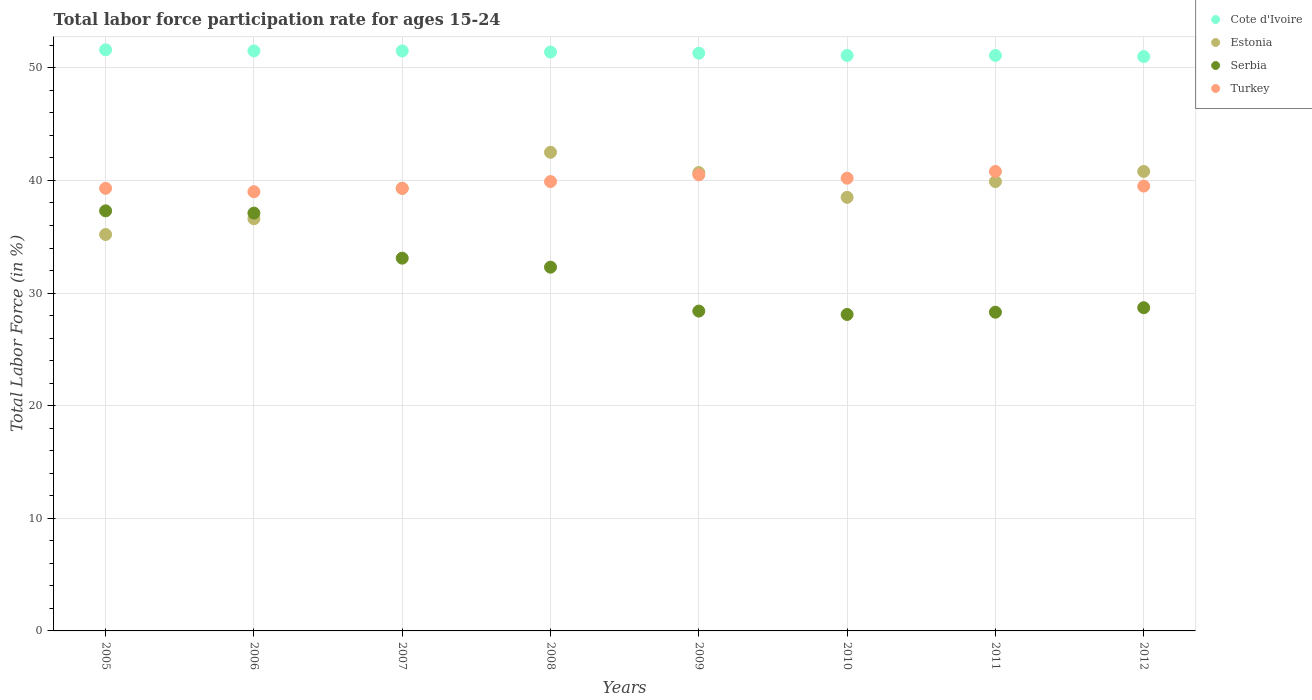What is the labor force participation rate in Turkey in 2009?
Your answer should be very brief. 40.5. Across all years, what is the maximum labor force participation rate in Estonia?
Offer a very short reply. 42.5. What is the total labor force participation rate in Serbia in the graph?
Offer a very short reply. 253.3. What is the average labor force participation rate in Serbia per year?
Ensure brevity in your answer.  31.66. In the year 2005, what is the difference between the labor force participation rate in Estonia and labor force participation rate in Turkey?
Give a very brief answer. -4.1. What is the ratio of the labor force participation rate in Estonia in 2006 to that in 2011?
Give a very brief answer. 0.92. Is the labor force participation rate in Estonia in 2007 less than that in 2012?
Give a very brief answer. Yes. What is the difference between the highest and the second highest labor force participation rate in Turkey?
Give a very brief answer. 0.3. What is the difference between the highest and the lowest labor force participation rate in Cote d'Ivoire?
Your answer should be very brief. 0.6. Is it the case that in every year, the sum of the labor force participation rate in Cote d'Ivoire and labor force participation rate in Serbia  is greater than the labor force participation rate in Turkey?
Your answer should be very brief. Yes. How many dotlines are there?
Keep it short and to the point. 4. What is the difference between two consecutive major ticks on the Y-axis?
Your answer should be very brief. 10. Are the values on the major ticks of Y-axis written in scientific E-notation?
Ensure brevity in your answer.  No. Does the graph contain any zero values?
Your answer should be compact. No. Does the graph contain grids?
Provide a succinct answer. Yes. How are the legend labels stacked?
Your answer should be compact. Vertical. What is the title of the graph?
Your response must be concise. Total labor force participation rate for ages 15-24. What is the Total Labor Force (in %) in Cote d'Ivoire in 2005?
Your answer should be very brief. 51.6. What is the Total Labor Force (in %) in Estonia in 2005?
Give a very brief answer. 35.2. What is the Total Labor Force (in %) of Serbia in 2005?
Offer a terse response. 37.3. What is the Total Labor Force (in %) in Turkey in 2005?
Provide a short and direct response. 39.3. What is the Total Labor Force (in %) in Cote d'Ivoire in 2006?
Provide a succinct answer. 51.5. What is the Total Labor Force (in %) of Estonia in 2006?
Offer a terse response. 36.6. What is the Total Labor Force (in %) in Serbia in 2006?
Keep it short and to the point. 37.1. What is the Total Labor Force (in %) in Turkey in 2006?
Give a very brief answer. 39. What is the Total Labor Force (in %) of Cote d'Ivoire in 2007?
Provide a succinct answer. 51.5. What is the Total Labor Force (in %) of Estonia in 2007?
Offer a terse response. 39.3. What is the Total Labor Force (in %) of Serbia in 2007?
Your answer should be compact. 33.1. What is the Total Labor Force (in %) in Turkey in 2007?
Provide a succinct answer. 39.3. What is the Total Labor Force (in %) in Cote d'Ivoire in 2008?
Ensure brevity in your answer.  51.4. What is the Total Labor Force (in %) in Estonia in 2008?
Your response must be concise. 42.5. What is the Total Labor Force (in %) in Serbia in 2008?
Make the answer very short. 32.3. What is the Total Labor Force (in %) of Turkey in 2008?
Your response must be concise. 39.9. What is the Total Labor Force (in %) in Cote d'Ivoire in 2009?
Provide a short and direct response. 51.3. What is the Total Labor Force (in %) in Estonia in 2009?
Your answer should be compact. 40.7. What is the Total Labor Force (in %) in Serbia in 2009?
Make the answer very short. 28.4. What is the Total Labor Force (in %) in Turkey in 2009?
Your answer should be very brief. 40.5. What is the Total Labor Force (in %) of Cote d'Ivoire in 2010?
Make the answer very short. 51.1. What is the Total Labor Force (in %) in Estonia in 2010?
Keep it short and to the point. 38.5. What is the Total Labor Force (in %) in Serbia in 2010?
Make the answer very short. 28.1. What is the Total Labor Force (in %) of Turkey in 2010?
Keep it short and to the point. 40.2. What is the Total Labor Force (in %) of Cote d'Ivoire in 2011?
Offer a very short reply. 51.1. What is the Total Labor Force (in %) in Estonia in 2011?
Offer a terse response. 39.9. What is the Total Labor Force (in %) in Serbia in 2011?
Provide a short and direct response. 28.3. What is the Total Labor Force (in %) of Turkey in 2011?
Your answer should be compact. 40.8. What is the Total Labor Force (in %) of Cote d'Ivoire in 2012?
Provide a succinct answer. 51. What is the Total Labor Force (in %) of Estonia in 2012?
Offer a terse response. 40.8. What is the Total Labor Force (in %) of Serbia in 2012?
Provide a succinct answer. 28.7. What is the Total Labor Force (in %) of Turkey in 2012?
Offer a very short reply. 39.5. Across all years, what is the maximum Total Labor Force (in %) of Cote d'Ivoire?
Provide a short and direct response. 51.6. Across all years, what is the maximum Total Labor Force (in %) of Estonia?
Give a very brief answer. 42.5. Across all years, what is the maximum Total Labor Force (in %) in Serbia?
Your answer should be very brief. 37.3. Across all years, what is the maximum Total Labor Force (in %) of Turkey?
Your answer should be compact. 40.8. Across all years, what is the minimum Total Labor Force (in %) in Cote d'Ivoire?
Your answer should be very brief. 51. Across all years, what is the minimum Total Labor Force (in %) in Estonia?
Provide a short and direct response. 35.2. Across all years, what is the minimum Total Labor Force (in %) in Serbia?
Provide a short and direct response. 28.1. What is the total Total Labor Force (in %) in Cote d'Ivoire in the graph?
Offer a very short reply. 410.5. What is the total Total Labor Force (in %) in Estonia in the graph?
Provide a succinct answer. 313.5. What is the total Total Labor Force (in %) of Serbia in the graph?
Your response must be concise. 253.3. What is the total Total Labor Force (in %) in Turkey in the graph?
Give a very brief answer. 318.5. What is the difference between the Total Labor Force (in %) of Estonia in 2005 and that in 2006?
Provide a succinct answer. -1.4. What is the difference between the Total Labor Force (in %) of Turkey in 2005 and that in 2006?
Offer a very short reply. 0.3. What is the difference between the Total Labor Force (in %) of Serbia in 2005 and that in 2007?
Your response must be concise. 4.2. What is the difference between the Total Labor Force (in %) in Turkey in 2005 and that in 2007?
Offer a very short reply. 0. What is the difference between the Total Labor Force (in %) of Cote d'Ivoire in 2005 and that in 2008?
Make the answer very short. 0.2. What is the difference between the Total Labor Force (in %) in Estonia in 2005 and that in 2008?
Offer a very short reply. -7.3. What is the difference between the Total Labor Force (in %) in Serbia in 2005 and that in 2009?
Your answer should be compact. 8.9. What is the difference between the Total Labor Force (in %) of Turkey in 2005 and that in 2009?
Offer a terse response. -1.2. What is the difference between the Total Labor Force (in %) of Cote d'Ivoire in 2005 and that in 2010?
Your answer should be compact. 0.5. What is the difference between the Total Labor Force (in %) of Estonia in 2005 and that in 2010?
Offer a very short reply. -3.3. What is the difference between the Total Labor Force (in %) of Serbia in 2005 and that in 2010?
Offer a very short reply. 9.2. What is the difference between the Total Labor Force (in %) of Cote d'Ivoire in 2005 and that in 2011?
Your response must be concise. 0.5. What is the difference between the Total Labor Force (in %) in Estonia in 2005 and that in 2011?
Your answer should be very brief. -4.7. What is the difference between the Total Labor Force (in %) of Cote d'Ivoire in 2005 and that in 2012?
Ensure brevity in your answer.  0.6. What is the difference between the Total Labor Force (in %) in Turkey in 2005 and that in 2012?
Offer a terse response. -0.2. What is the difference between the Total Labor Force (in %) of Cote d'Ivoire in 2006 and that in 2007?
Ensure brevity in your answer.  0. What is the difference between the Total Labor Force (in %) of Serbia in 2006 and that in 2007?
Provide a short and direct response. 4. What is the difference between the Total Labor Force (in %) of Turkey in 2006 and that in 2007?
Offer a terse response. -0.3. What is the difference between the Total Labor Force (in %) of Estonia in 2006 and that in 2008?
Your answer should be compact. -5.9. What is the difference between the Total Labor Force (in %) in Serbia in 2006 and that in 2008?
Provide a short and direct response. 4.8. What is the difference between the Total Labor Force (in %) of Turkey in 2006 and that in 2008?
Provide a short and direct response. -0.9. What is the difference between the Total Labor Force (in %) in Cote d'Ivoire in 2006 and that in 2009?
Keep it short and to the point. 0.2. What is the difference between the Total Labor Force (in %) in Serbia in 2006 and that in 2009?
Make the answer very short. 8.7. What is the difference between the Total Labor Force (in %) of Turkey in 2006 and that in 2009?
Make the answer very short. -1.5. What is the difference between the Total Labor Force (in %) in Estonia in 2006 and that in 2010?
Make the answer very short. -1.9. What is the difference between the Total Labor Force (in %) in Serbia in 2006 and that in 2010?
Your answer should be very brief. 9. What is the difference between the Total Labor Force (in %) of Cote d'Ivoire in 2006 and that in 2011?
Ensure brevity in your answer.  0.4. What is the difference between the Total Labor Force (in %) of Serbia in 2006 and that in 2011?
Offer a very short reply. 8.8. What is the difference between the Total Labor Force (in %) in Cote d'Ivoire in 2006 and that in 2012?
Offer a terse response. 0.5. What is the difference between the Total Labor Force (in %) in Estonia in 2006 and that in 2012?
Your answer should be compact. -4.2. What is the difference between the Total Labor Force (in %) in Serbia in 2006 and that in 2012?
Give a very brief answer. 8.4. What is the difference between the Total Labor Force (in %) in Turkey in 2006 and that in 2012?
Make the answer very short. -0.5. What is the difference between the Total Labor Force (in %) of Cote d'Ivoire in 2007 and that in 2008?
Make the answer very short. 0.1. What is the difference between the Total Labor Force (in %) of Estonia in 2007 and that in 2008?
Provide a succinct answer. -3.2. What is the difference between the Total Labor Force (in %) in Serbia in 2007 and that in 2008?
Your answer should be very brief. 0.8. What is the difference between the Total Labor Force (in %) of Turkey in 2007 and that in 2008?
Keep it short and to the point. -0.6. What is the difference between the Total Labor Force (in %) of Turkey in 2007 and that in 2009?
Make the answer very short. -1.2. What is the difference between the Total Labor Force (in %) in Cote d'Ivoire in 2007 and that in 2010?
Keep it short and to the point. 0.4. What is the difference between the Total Labor Force (in %) in Estonia in 2007 and that in 2011?
Provide a short and direct response. -0.6. What is the difference between the Total Labor Force (in %) of Turkey in 2007 and that in 2011?
Provide a succinct answer. -1.5. What is the difference between the Total Labor Force (in %) in Cote d'Ivoire in 2007 and that in 2012?
Offer a terse response. 0.5. What is the difference between the Total Labor Force (in %) in Estonia in 2007 and that in 2012?
Ensure brevity in your answer.  -1.5. What is the difference between the Total Labor Force (in %) of Serbia in 2007 and that in 2012?
Ensure brevity in your answer.  4.4. What is the difference between the Total Labor Force (in %) of Turkey in 2007 and that in 2012?
Your answer should be very brief. -0.2. What is the difference between the Total Labor Force (in %) in Cote d'Ivoire in 2008 and that in 2009?
Provide a succinct answer. 0.1. What is the difference between the Total Labor Force (in %) of Turkey in 2008 and that in 2009?
Provide a succinct answer. -0.6. What is the difference between the Total Labor Force (in %) of Cote d'Ivoire in 2008 and that in 2011?
Your answer should be very brief. 0.3. What is the difference between the Total Labor Force (in %) of Estonia in 2008 and that in 2011?
Your answer should be very brief. 2.6. What is the difference between the Total Labor Force (in %) of Serbia in 2008 and that in 2011?
Provide a succinct answer. 4. What is the difference between the Total Labor Force (in %) in Turkey in 2008 and that in 2011?
Your response must be concise. -0.9. What is the difference between the Total Labor Force (in %) in Cote d'Ivoire in 2008 and that in 2012?
Provide a succinct answer. 0.4. What is the difference between the Total Labor Force (in %) in Serbia in 2008 and that in 2012?
Provide a succinct answer. 3.6. What is the difference between the Total Labor Force (in %) in Estonia in 2009 and that in 2010?
Offer a terse response. 2.2. What is the difference between the Total Labor Force (in %) in Serbia in 2009 and that in 2010?
Keep it short and to the point. 0.3. What is the difference between the Total Labor Force (in %) of Turkey in 2009 and that in 2010?
Give a very brief answer. 0.3. What is the difference between the Total Labor Force (in %) in Estonia in 2009 and that in 2011?
Make the answer very short. 0.8. What is the difference between the Total Labor Force (in %) in Turkey in 2009 and that in 2011?
Offer a very short reply. -0.3. What is the difference between the Total Labor Force (in %) of Turkey in 2009 and that in 2012?
Ensure brevity in your answer.  1. What is the difference between the Total Labor Force (in %) of Cote d'Ivoire in 2010 and that in 2011?
Your response must be concise. 0. What is the difference between the Total Labor Force (in %) of Estonia in 2010 and that in 2011?
Offer a very short reply. -1.4. What is the difference between the Total Labor Force (in %) of Serbia in 2010 and that in 2011?
Provide a short and direct response. -0.2. What is the difference between the Total Labor Force (in %) in Turkey in 2010 and that in 2011?
Your answer should be compact. -0.6. What is the difference between the Total Labor Force (in %) of Cote d'Ivoire in 2010 and that in 2012?
Your response must be concise. 0.1. What is the difference between the Total Labor Force (in %) in Estonia in 2010 and that in 2012?
Offer a very short reply. -2.3. What is the difference between the Total Labor Force (in %) of Serbia in 2010 and that in 2012?
Keep it short and to the point. -0.6. What is the difference between the Total Labor Force (in %) in Turkey in 2010 and that in 2012?
Give a very brief answer. 0.7. What is the difference between the Total Labor Force (in %) in Cote d'Ivoire in 2011 and that in 2012?
Offer a very short reply. 0.1. What is the difference between the Total Labor Force (in %) in Estonia in 2011 and that in 2012?
Provide a short and direct response. -0.9. What is the difference between the Total Labor Force (in %) of Serbia in 2011 and that in 2012?
Your answer should be compact. -0.4. What is the difference between the Total Labor Force (in %) of Turkey in 2011 and that in 2012?
Offer a very short reply. 1.3. What is the difference between the Total Labor Force (in %) in Cote d'Ivoire in 2005 and the Total Labor Force (in %) in Turkey in 2006?
Your answer should be very brief. 12.6. What is the difference between the Total Labor Force (in %) in Estonia in 2005 and the Total Labor Force (in %) in Turkey in 2006?
Offer a terse response. -3.8. What is the difference between the Total Labor Force (in %) in Cote d'Ivoire in 2005 and the Total Labor Force (in %) in Estonia in 2007?
Your response must be concise. 12.3. What is the difference between the Total Labor Force (in %) of Cote d'Ivoire in 2005 and the Total Labor Force (in %) of Turkey in 2007?
Give a very brief answer. 12.3. What is the difference between the Total Labor Force (in %) of Estonia in 2005 and the Total Labor Force (in %) of Serbia in 2007?
Ensure brevity in your answer.  2.1. What is the difference between the Total Labor Force (in %) in Estonia in 2005 and the Total Labor Force (in %) in Turkey in 2007?
Offer a terse response. -4.1. What is the difference between the Total Labor Force (in %) of Cote d'Ivoire in 2005 and the Total Labor Force (in %) of Estonia in 2008?
Provide a short and direct response. 9.1. What is the difference between the Total Labor Force (in %) of Cote d'Ivoire in 2005 and the Total Labor Force (in %) of Serbia in 2008?
Provide a succinct answer. 19.3. What is the difference between the Total Labor Force (in %) in Cote d'Ivoire in 2005 and the Total Labor Force (in %) in Turkey in 2008?
Give a very brief answer. 11.7. What is the difference between the Total Labor Force (in %) in Serbia in 2005 and the Total Labor Force (in %) in Turkey in 2008?
Offer a very short reply. -2.6. What is the difference between the Total Labor Force (in %) of Cote d'Ivoire in 2005 and the Total Labor Force (in %) of Serbia in 2009?
Your response must be concise. 23.2. What is the difference between the Total Labor Force (in %) in Cote d'Ivoire in 2005 and the Total Labor Force (in %) in Turkey in 2009?
Provide a succinct answer. 11.1. What is the difference between the Total Labor Force (in %) in Serbia in 2005 and the Total Labor Force (in %) in Turkey in 2009?
Your response must be concise. -3.2. What is the difference between the Total Labor Force (in %) in Cote d'Ivoire in 2005 and the Total Labor Force (in %) in Serbia in 2010?
Ensure brevity in your answer.  23.5. What is the difference between the Total Labor Force (in %) of Estonia in 2005 and the Total Labor Force (in %) of Serbia in 2010?
Your response must be concise. 7.1. What is the difference between the Total Labor Force (in %) of Estonia in 2005 and the Total Labor Force (in %) of Turkey in 2010?
Give a very brief answer. -5. What is the difference between the Total Labor Force (in %) of Serbia in 2005 and the Total Labor Force (in %) of Turkey in 2010?
Your response must be concise. -2.9. What is the difference between the Total Labor Force (in %) of Cote d'Ivoire in 2005 and the Total Labor Force (in %) of Serbia in 2011?
Give a very brief answer. 23.3. What is the difference between the Total Labor Force (in %) in Serbia in 2005 and the Total Labor Force (in %) in Turkey in 2011?
Provide a short and direct response. -3.5. What is the difference between the Total Labor Force (in %) in Cote d'Ivoire in 2005 and the Total Labor Force (in %) in Estonia in 2012?
Ensure brevity in your answer.  10.8. What is the difference between the Total Labor Force (in %) of Cote d'Ivoire in 2005 and the Total Labor Force (in %) of Serbia in 2012?
Keep it short and to the point. 22.9. What is the difference between the Total Labor Force (in %) in Cote d'Ivoire in 2005 and the Total Labor Force (in %) in Turkey in 2012?
Ensure brevity in your answer.  12.1. What is the difference between the Total Labor Force (in %) in Estonia in 2005 and the Total Labor Force (in %) in Serbia in 2012?
Keep it short and to the point. 6.5. What is the difference between the Total Labor Force (in %) in Estonia in 2005 and the Total Labor Force (in %) in Turkey in 2012?
Make the answer very short. -4.3. What is the difference between the Total Labor Force (in %) in Estonia in 2006 and the Total Labor Force (in %) in Serbia in 2007?
Provide a short and direct response. 3.5. What is the difference between the Total Labor Force (in %) in Estonia in 2006 and the Total Labor Force (in %) in Turkey in 2007?
Make the answer very short. -2.7. What is the difference between the Total Labor Force (in %) in Cote d'Ivoire in 2006 and the Total Labor Force (in %) in Turkey in 2008?
Give a very brief answer. 11.6. What is the difference between the Total Labor Force (in %) of Serbia in 2006 and the Total Labor Force (in %) of Turkey in 2008?
Ensure brevity in your answer.  -2.8. What is the difference between the Total Labor Force (in %) of Cote d'Ivoire in 2006 and the Total Labor Force (in %) of Serbia in 2009?
Make the answer very short. 23.1. What is the difference between the Total Labor Force (in %) of Serbia in 2006 and the Total Labor Force (in %) of Turkey in 2009?
Provide a short and direct response. -3.4. What is the difference between the Total Labor Force (in %) in Cote d'Ivoire in 2006 and the Total Labor Force (in %) in Estonia in 2010?
Ensure brevity in your answer.  13. What is the difference between the Total Labor Force (in %) in Cote d'Ivoire in 2006 and the Total Labor Force (in %) in Serbia in 2010?
Your answer should be very brief. 23.4. What is the difference between the Total Labor Force (in %) of Estonia in 2006 and the Total Labor Force (in %) of Serbia in 2010?
Give a very brief answer. 8.5. What is the difference between the Total Labor Force (in %) in Serbia in 2006 and the Total Labor Force (in %) in Turkey in 2010?
Your answer should be very brief. -3.1. What is the difference between the Total Labor Force (in %) in Cote d'Ivoire in 2006 and the Total Labor Force (in %) in Estonia in 2011?
Your response must be concise. 11.6. What is the difference between the Total Labor Force (in %) of Cote d'Ivoire in 2006 and the Total Labor Force (in %) of Serbia in 2011?
Make the answer very short. 23.2. What is the difference between the Total Labor Force (in %) in Cote d'Ivoire in 2006 and the Total Labor Force (in %) in Turkey in 2011?
Offer a terse response. 10.7. What is the difference between the Total Labor Force (in %) in Estonia in 2006 and the Total Labor Force (in %) in Serbia in 2011?
Your response must be concise. 8.3. What is the difference between the Total Labor Force (in %) in Estonia in 2006 and the Total Labor Force (in %) in Turkey in 2011?
Ensure brevity in your answer.  -4.2. What is the difference between the Total Labor Force (in %) of Serbia in 2006 and the Total Labor Force (in %) of Turkey in 2011?
Keep it short and to the point. -3.7. What is the difference between the Total Labor Force (in %) in Cote d'Ivoire in 2006 and the Total Labor Force (in %) in Serbia in 2012?
Provide a succinct answer. 22.8. What is the difference between the Total Labor Force (in %) of Cote d'Ivoire in 2006 and the Total Labor Force (in %) of Turkey in 2012?
Your answer should be very brief. 12. What is the difference between the Total Labor Force (in %) in Estonia in 2006 and the Total Labor Force (in %) in Turkey in 2012?
Ensure brevity in your answer.  -2.9. What is the difference between the Total Labor Force (in %) in Cote d'Ivoire in 2007 and the Total Labor Force (in %) in Estonia in 2008?
Offer a very short reply. 9. What is the difference between the Total Labor Force (in %) of Cote d'Ivoire in 2007 and the Total Labor Force (in %) of Turkey in 2008?
Provide a short and direct response. 11.6. What is the difference between the Total Labor Force (in %) in Cote d'Ivoire in 2007 and the Total Labor Force (in %) in Estonia in 2009?
Your answer should be very brief. 10.8. What is the difference between the Total Labor Force (in %) in Cote d'Ivoire in 2007 and the Total Labor Force (in %) in Serbia in 2009?
Make the answer very short. 23.1. What is the difference between the Total Labor Force (in %) in Cote d'Ivoire in 2007 and the Total Labor Force (in %) in Turkey in 2009?
Give a very brief answer. 11. What is the difference between the Total Labor Force (in %) of Estonia in 2007 and the Total Labor Force (in %) of Serbia in 2009?
Give a very brief answer. 10.9. What is the difference between the Total Labor Force (in %) of Serbia in 2007 and the Total Labor Force (in %) of Turkey in 2009?
Give a very brief answer. -7.4. What is the difference between the Total Labor Force (in %) in Cote d'Ivoire in 2007 and the Total Labor Force (in %) in Estonia in 2010?
Your answer should be very brief. 13. What is the difference between the Total Labor Force (in %) in Cote d'Ivoire in 2007 and the Total Labor Force (in %) in Serbia in 2010?
Your answer should be very brief. 23.4. What is the difference between the Total Labor Force (in %) in Cote d'Ivoire in 2007 and the Total Labor Force (in %) in Turkey in 2010?
Provide a succinct answer. 11.3. What is the difference between the Total Labor Force (in %) in Estonia in 2007 and the Total Labor Force (in %) in Serbia in 2010?
Keep it short and to the point. 11.2. What is the difference between the Total Labor Force (in %) of Estonia in 2007 and the Total Labor Force (in %) of Turkey in 2010?
Your answer should be compact. -0.9. What is the difference between the Total Labor Force (in %) of Cote d'Ivoire in 2007 and the Total Labor Force (in %) of Serbia in 2011?
Keep it short and to the point. 23.2. What is the difference between the Total Labor Force (in %) in Cote d'Ivoire in 2007 and the Total Labor Force (in %) in Turkey in 2011?
Your response must be concise. 10.7. What is the difference between the Total Labor Force (in %) of Estonia in 2007 and the Total Labor Force (in %) of Turkey in 2011?
Keep it short and to the point. -1.5. What is the difference between the Total Labor Force (in %) of Cote d'Ivoire in 2007 and the Total Labor Force (in %) of Serbia in 2012?
Your response must be concise. 22.8. What is the difference between the Total Labor Force (in %) of Cote d'Ivoire in 2007 and the Total Labor Force (in %) of Turkey in 2012?
Your response must be concise. 12. What is the difference between the Total Labor Force (in %) of Estonia in 2007 and the Total Labor Force (in %) of Turkey in 2012?
Your answer should be very brief. -0.2. What is the difference between the Total Labor Force (in %) of Serbia in 2007 and the Total Labor Force (in %) of Turkey in 2012?
Your response must be concise. -6.4. What is the difference between the Total Labor Force (in %) of Cote d'Ivoire in 2008 and the Total Labor Force (in %) of Serbia in 2010?
Your answer should be compact. 23.3. What is the difference between the Total Labor Force (in %) of Cote d'Ivoire in 2008 and the Total Labor Force (in %) of Turkey in 2010?
Provide a short and direct response. 11.2. What is the difference between the Total Labor Force (in %) in Estonia in 2008 and the Total Labor Force (in %) in Serbia in 2010?
Offer a very short reply. 14.4. What is the difference between the Total Labor Force (in %) of Estonia in 2008 and the Total Labor Force (in %) of Turkey in 2010?
Your response must be concise. 2.3. What is the difference between the Total Labor Force (in %) of Serbia in 2008 and the Total Labor Force (in %) of Turkey in 2010?
Your answer should be compact. -7.9. What is the difference between the Total Labor Force (in %) in Cote d'Ivoire in 2008 and the Total Labor Force (in %) in Estonia in 2011?
Offer a terse response. 11.5. What is the difference between the Total Labor Force (in %) of Cote d'Ivoire in 2008 and the Total Labor Force (in %) of Serbia in 2011?
Your answer should be very brief. 23.1. What is the difference between the Total Labor Force (in %) of Cote d'Ivoire in 2008 and the Total Labor Force (in %) of Turkey in 2011?
Make the answer very short. 10.6. What is the difference between the Total Labor Force (in %) in Cote d'Ivoire in 2008 and the Total Labor Force (in %) in Estonia in 2012?
Your answer should be compact. 10.6. What is the difference between the Total Labor Force (in %) in Cote d'Ivoire in 2008 and the Total Labor Force (in %) in Serbia in 2012?
Offer a very short reply. 22.7. What is the difference between the Total Labor Force (in %) in Cote d'Ivoire in 2008 and the Total Labor Force (in %) in Turkey in 2012?
Ensure brevity in your answer.  11.9. What is the difference between the Total Labor Force (in %) of Estonia in 2008 and the Total Labor Force (in %) of Serbia in 2012?
Give a very brief answer. 13.8. What is the difference between the Total Labor Force (in %) of Cote d'Ivoire in 2009 and the Total Labor Force (in %) of Estonia in 2010?
Keep it short and to the point. 12.8. What is the difference between the Total Labor Force (in %) of Cote d'Ivoire in 2009 and the Total Labor Force (in %) of Serbia in 2010?
Provide a succinct answer. 23.2. What is the difference between the Total Labor Force (in %) in Cote d'Ivoire in 2009 and the Total Labor Force (in %) in Turkey in 2010?
Your response must be concise. 11.1. What is the difference between the Total Labor Force (in %) in Serbia in 2009 and the Total Labor Force (in %) in Turkey in 2010?
Keep it short and to the point. -11.8. What is the difference between the Total Labor Force (in %) of Cote d'Ivoire in 2009 and the Total Labor Force (in %) of Turkey in 2011?
Keep it short and to the point. 10.5. What is the difference between the Total Labor Force (in %) of Estonia in 2009 and the Total Labor Force (in %) of Serbia in 2011?
Provide a short and direct response. 12.4. What is the difference between the Total Labor Force (in %) in Estonia in 2009 and the Total Labor Force (in %) in Turkey in 2011?
Provide a short and direct response. -0.1. What is the difference between the Total Labor Force (in %) in Serbia in 2009 and the Total Labor Force (in %) in Turkey in 2011?
Your answer should be compact. -12.4. What is the difference between the Total Labor Force (in %) of Cote d'Ivoire in 2009 and the Total Labor Force (in %) of Estonia in 2012?
Give a very brief answer. 10.5. What is the difference between the Total Labor Force (in %) of Cote d'Ivoire in 2009 and the Total Labor Force (in %) of Serbia in 2012?
Provide a succinct answer. 22.6. What is the difference between the Total Labor Force (in %) of Cote d'Ivoire in 2009 and the Total Labor Force (in %) of Turkey in 2012?
Offer a very short reply. 11.8. What is the difference between the Total Labor Force (in %) of Estonia in 2009 and the Total Labor Force (in %) of Turkey in 2012?
Provide a short and direct response. 1.2. What is the difference between the Total Labor Force (in %) in Cote d'Ivoire in 2010 and the Total Labor Force (in %) in Estonia in 2011?
Make the answer very short. 11.2. What is the difference between the Total Labor Force (in %) of Cote d'Ivoire in 2010 and the Total Labor Force (in %) of Serbia in 2011?
Provide a short and direct response. 22.8. What is the difference between the Total Labor Force (in %) in Cote d'Ivoire in 2010 and the Total Labor Force (in %) in Turkey in 2011?
Your answer should be compact. 10.3. What is the difference between the Total Labor Force (in %) of Estonia in 2010 and the Total Labor Force (in %) of Serbia in 2011?
Provide a succinct answer. 10.2. What is the difference between the Total Labor Force (in %) in Serbia in 2010 and the Total Labor Force (in %) in Turkey in 2011?
Provide a short and direct response. -12.7. What is the difference between the Total Labor Force (in %) in Cote d'Ivoire in 2010 and the Total Labor Force (in %) in Estonia in 2012?
Offer a terse response. 10.3. What is the difference between the Total Labor Force (in %) in Cote d'Ivoire in 2010 and the Total Labor Force (in %) in Serbia in 2012?
Your answer should be very brief. 22.4. What is the difference between the Total Labor Force (in %) of Cote d'Ivoire in 2010 and the Total Labor Force (in %) of Turkey in 2012?
Offer a very short reply. 11.6. What is the difference between the Total Labor Force (in %) of Cote d'Ivoire in 2011 and the Total Labor Force (in %) of Serbia in 2012?
Keep it short and to the point. 22.4. What is the difference between the Total Labor Force (in %) of Estonia in 2011 and the Total Labor Force (in %) of Turkey in 2012?
Make the answer very short. 0.4. What is the difference between the Total Labor Force (in %) of Serbia in 2011 and the Total Labor Force (in %) of Turkey in 2012?
Provide a succinct answer. -11.2. What is the average Total Labor Force (in %) of Cote d'Ivoire per year?
Provide a succinct answer. 51.31. What is the average Total Labor Force (in %) of Estonia per year?
Your answer should be very brief. 39.19. What is the average Total Labor Force (in %) of Serbia per year?
Ensure brevity in your answer.  31.66. What is the average Total Labor Force (in %) in Turkey per year?
Offer a very short reply. 39.81. In the year 2005, what is the difference between the Total Labor Force (in %) of Cote d'Ivoire and Total Labor Force (in %) of Serbia?
Offer a very short reply. 14.3. In the year 2005, what is the difference between the Total Labor Force (in %) in Cote d'Ivoire and Total Labor Force (in %) in Turkey?
Offer a terse response. 12.3. In the year 2005, what is the difference between the Total Labor Force (in %) of Estonia and Total Labor Force (in %) of Serbia?
Offer a terse response. -2.1. In the year 2005, what is the difference between the Total Labor Force (in %) in Estonia and Total Labor Force (in %) in Turkey?
Make the answer very short. -4.1. In the year 2005, what is the difference between the Total Labor Force (in %) of Serbia and Total Labor Force (in %) of Turkey?
Your answer should be very brief. -2. In the year 2006, what is the difference between the Total Labor Force (in %) of Cote d'Ivoire and Total Labor Force (in %) of Estonia?
Your answer should be very brief. 14.9. In the year 2006, what is the difference between the Total Labor Force (in %) in Cote d'Ivoire and Total Labor Force (in %) in Serbia?
Offer a very short reply. 14.4. In the year 2006, what is the difference between the Total Labor Force (in %) in Estonia and Total Labor Force (in %) in Serbia?
Give a very brief answer. -0.5. In the year 2006, what is the difference between the Total Labor Force (in %) of Estonia and Total Labor Force (in %) of Turkey?
Provide a short and direct response. -2.4. In the year 2007, what is the difference between the Total Labor Force (in %) of Cote d'Ivoire and Total Labor Force (in %) of Turkey?
Give a very brief answer. 12.2. In the year 2007, what is the difference between the Total Labor Force (in %) in Estonia and Total Labor Force (in %) in Serbia?
Provide a succinct answer. 6.2. In the year 2007, what is the difference between the Total Labor Force (in %) in Estonia and Total Labor Force (in %) in Turkey?
Offer a terse response. 0. In the year 2007, what is the difference between the Total Labor Force (in %) of Serbia and Total Labor Force (in %) of Turkey?
Your answer should be very brief. -6.2. In the year 2008, what is the difference between the Total Labor Force (in %) in Cote d'Ivoire and Total Labor Force (in %) in Serbia?
Give a very brief answer. 19.1. In the year 2008, what is the difference between the Total Labor Force (in %) of Estonia and Total Labor Force (in %) of Turkey?
Make the answer very short. 2.6. In the year 2009, what is the difference between the Total Labor Force (in %) in Cote d'Ivoire and Total Labor Force (in %) in Estonia?
Offer a terse response. 10.6. In the year 2009, what is the difference between the Total Labor Force (in %) of Cote d'Ivoire and Total Labor Force (in %) of Serbia?
Provide a short and direct response. 22.9. In the year 2009, what is the difference between the Total Labor Force (in %) in Cote d'Ivoire and Total Labor Force (in %) in Turkey?
Your response must be concise. 10.8. In the year 2009, what is the difference between the Total Labor Force (in %) in Serbia and Total Labor Force (in %) in Turkey?
Provide a succinct answer. -12.1. In the year 2010, what is the difference between the Total Labor Force (in %) in Cote d'Ivoire and Total Labor Force (in %) in Estonia?
Provide a short and direct response. 12.6. In the year 2010, what is the difference between the Total Labor Force (in %) of Cote d'Ivoire and Total Labor Force (in %) of Turkey?
Ensure brevity in your answer.  10.9. In the year 2010, what is the difference between the Total Labor Force (in %) of Estonia and Total Labor Force (in %) of Serbia?
Keep it short and to the point. 10.4. In the year 2010, what is the difference between the Total Labor Force (in %) in Serbia and Total Labor Force (in %) in Turkey?
Make the answer very short. -12.1. In the year 2011, what is the difference between the Total Labor Force (in %) in Cote d'Ivoire and Total Labor Force (in %) in Estonia?
Offer a terse response. 11.2. In the year 2011, what is the difference between the Total Labor Force (in %) in Cote d'Ivoire and Total Labor Force (in %) in Serbia?
Your answer should be very brief. 22.8. In the year 2011, what is the difference between the Total Labor Force (in %) in Serbia and Total Labor Force (in %) in Turkey?
Keep it short and to the point. -12.5. In the year 2012, what is the difference between the Total Labor Force (in %) in Cote d'Ivoire and Total Labor Force (in %) in Serbia?
Offer a very short reply. 22.3. In the year 2012, what is the difference between the Total Labor Force (in %) in Cote d'Ivoire and Total Labor Force (in %) in Turkey?
Your answer should be compact. 11.5. In the year 2012, what is the difference between the Total Labor Force (in %) of Estonia and Total Labor Force (in %) of Serbia?
Your answer should be very brief. 12.1. In the year 2012, what is the difference between the Total Labor Force (in %) of Serbia and Total Labor Force (in %) of Turkey?
Give a very brief answer. -10.8. What is the ratio of the Total Labor Force (in %) in Cote d'Ivoire in 2005 to that in 2006?
Your response must be concise. 1. What is the ratio of the Total Labor Force (in %) in Estonia in 2005 to that in 2006?
Offer a terse response. 0.96. What is the ratio of the Total Labor Force (in %) of Serbia in 2005 to that in 2006?
Make the answer very short. 1.01. What is the ratio of the Total Labor Force (in %) in Turkey in 2005 to that in 2006?
Ensure brevity in your answer.  1.01. What is the ratio of the Total Labor Force (in %) in Cote d'Ivoire in 2005 to that in 2007?
Offer a very short reply. 1. What is the ratio of the Total Labor Force (in %) of Estonia in 2005 to that in 2007?
Your response must be concise. 0.9. What is the ratio of the Total Labor Force (in %) in Serbia in 2005 to that in 2007?
Ensure brevity in your answer.  1.13. What is the ratio of the Total Labor Force (in %) in Cote d'Ivoire in 2005 to that in 2008?
Provide a short and direct response. 1. What is the ratio of the Total Labor Force (in %) in Estonia in 2005 to that in 2008?
Your answer should be very brief. 0.83. What is the ratio of the Total Labor Force (in %) in Serbia in 2005 to that in 2008?
Your answer should be compact. 1.15. What is the ratio of the Total Labor Force (in %) in Turkey in 2005 to that in 2008?
Give a very brief answer. 0.98. What is the ratio of the Total Labor Force (in %) of Cote d'Ivoire in 2005 to that in 2009?
Ensure brevity in your answer.  1.01. What is the ratio of the Total Labor Force (in %) in Estonia in 2005 to that in 2009?
Provide a succinct answer. 0.86. What is the ratio of the Total Labor Force (in %) of Serbia in 2005 to that in 2009?
Provide a succinct answer. 1.31. What is the ratio of the Total Labor Force (in %) in Turkey in 2005 to that in 2009?
Offer a very short reply. 0.97. What is the ratio of the Total Labor Force (in %) of Cote d'Ivoire in 2005 to that in 2010?
Make the answer very short. 1.01. What is the ratio of the Total Labor Force (in %) of Estonia in 2005 to that in 2010?
Keep it short and to the point. 0.91. What is the ratio of the Total Labor Force (in %) of Serbia in 2005 to that in 2010?
Provide a short and direct response. 1.33. What is the ratio of the Total Labor Force (in %) in Turkey in 2005 to that in 2010?
Your response must be concise. 0.98. What is the ratio of the Total Labor Force (in %) in Cote d'Ivoire in 2005 to that in 2011?
Make the answer very short. 1.01. What is the ratio of the Total Labor Force (in %) in Estonia in 2005 to that in 2011?
Provide a succinct answer. 0.88. What is the ratio of the Total Labor Force (in %) of Serbia in 2005 to that in 2011?
Provide a short and direct response. 1.32. What is the ratio of the Total Labor Force (in %) of Turkey in 2005 to that in 2011?
Your answer should be very brief. 0.96. What is the ratio of the Total Labor Force (in %) in Cote d'Ivoire in 2005 to that in 2012?
Your response must be concise. 1.01. What is the ratio of the Total Labor Force (in %) of Estonia in 2005 to that in 2012?
Provide a short and direct response. 0.86. What is the ratio of the Total Labor Force (in %) in Serbia in 2005 to that in 2012?
Provide a short and direct response. 1.3. What is the ratio of the Total Labor Force (in %) in Cote d'Ivoire in 2006 to that in 2007?
Offer a very short reply. 1. What is the ratio of the Total Labor Force (in %) in Estonia in 2006 to that in 2007?
Keep it short and to the point. 0.93. What is the ratio of the Total Labor Force (in %) of Serbia in 2006 to that in 2007?
Provide a succinct answer. 1.12. What is the ratio of the Total Labor Force (in %) in Cote d'Ivoire in 2006 to that in 2008?
Give a very brief answer. 1. What is the ratio of the Total Labor Force (in %) in Estonia in 2006 to that in 2008?
Ensure brevity in your answer.  0.86. What is the ratio of the Total Labor Force (in %) of Serbia in 2006 to that in 2008?
Offer a very short reply. 1.15. What is the ratio of the Total Labor Force (in %) of Turkey in 2006 to that in 2008?
Your response must be concise. 0.98. What is the ratio of the Total Labor Force (in %) in Cote d'Ivoire in 2006 to that in 2009?
Provide a short and direct response. 1. What is the ratio of the Total Labor Force (in %) of Estonia in 2006 to that in 2009?
Make the answer very short. 0.9. What is the ratio of the Total Labor Force (in %) of Serbia in 2006 to that in 2009?
Make the answer very short. 1.31. What is the ratio of the Total Labor Force (in %) in Estonia in 2006 to that in 2010?
Offer a very short reply. 0.95. What is the ratio of the Total Labor Force (in %) in Serbia in 2006 to that in 2010?
Offer a terse response. 1.32. What is the ratio of the Total Labor Force (in %) in Turkey in 2006 to that in 2010?
Provide a short and direct response. 0.97. What is the ratio of the Total Labor Force (in %) in Cote d'Ivoire in 2006 to that in 2011?
Your answer should be compact. 1.01. What is the ratio of the Total Labor Force (in %) of Estonia in 2006 to that in 2011?
Your answer should be compact. 0.92. What is the ratio of the Total Labor Force (in %) in Serbia in 2006 to that in 2011?
Offer a very short reply. 1.31. What is the ratio of the Total Labor Force (in %) of Turkey in 2006 to that in 2011?
Provide a succinct answer. 0.96. What is the ratio of the Total Labor Force (in %) of Cote d'Ivoire in 2006 to that in 2012?
Offer a terse response. 1.01. What is the ratio of the Total Labor Force (in %) in Estonia in 2006 to that in 2012?
Give a very brief answer. 0.9. What is the ratio of the Total Labor Force (in %) in Serbia in 2006 to that in 2012?
Your answer should be compact. 1.29. What is the ratio of the Total Labor Force (in %) of Turkey in 2006 to that in 2012?
Your answer should be compact. 0.99. What is the ratio of the Total Labor Force (in %) in Estonia in 2007 to that in 2008?
Your response must be concise. 0.92. What is the ratio of the Total Labor Force (in %) of Serbia in 2007 to that in 2008?
Provide a short and direct response. 1.02. What is the ratio of the Total Labor Force (in %) in Turkey in 2007 to that in 2008?
Offer a terse response. 0.98. What is the ratio of the Total Labor Force (in %) of Estonia in 2007 to that in 2009?
Your response must be concise. 0.97. What is the ratio of the Total Labor Force (in %) in Serbia in 2007 to that in 2009?
Your answer should be compact. 1.17. What is the ratio of the Total Labor Force (in %) of Turkey in 2007 to that in 2009?
Your answer should be very brief. 0.97. What is the ratio of the Total Labor Force (in %) of Estonia in 2007 to that in 2010?
Keep it short and to the point. 1.02. What is the ratio of the Total Labor Force (in %) of Serbia in 2007 to that in 2010?
Provide a short and direct response. 1.18. What is the ratio of the Total Labor Force (in %) of Turkey in 2007 to that in 2010?
Provide a short and direct response. 0.98. What is the ratio of the Total Labor Force (in %) in Cote d'Ivoire in 2007 to that in 2011?
Your answer should be very brief. 1.01. What is the ratio of the Total Labor Force (in %) in Estonia in 2007 to that in 2011?
Offer a terse response. 0.98. What is the ratio of the Total Labor Force (in %) of Serbia in 2007 to that in 2011?
Make the answer very short. 1.17. What is the ratio of the Total Labor Force (in %) in Turkey in 2007 to that in 2011?
Provide a short and direct response. 0.96. What is the ratio of the Total Labor Force (in %) in Cote d'Ivoire in 2007 to that in 2012?
Offer a very short reply. 1.01. What is the ratio of the Total Labor Force (in %) in Estonia in 2007 to that in 2012?
Ensure brevity in your answer.  0.96. What is the ratio of the Total Labor Force (in %) of Serbia in 2007 to that in 2012?
Your answer should be very brief. 1.15. What is the ratio of the Total Labor Force (in %) in Turkey in 2007 to that in 2012?
Keep it short and to the point. 0.99. What is the ratio of the Total Labor Force (in %) of Cote d'Ivoire in 2008 to that in 2009?
Provide a succinct answer. 1. What is the ratio of the Total Labor Force (in %) in Estonia in 2008 to that in 2009?
Provide a succinct answer. 1.04. What is the ratio of the Total Labor Force (in %) of Serbia in 2008 to that in 2009?
Your answer should be very brief. 1.14. What is the ratio of the Total Labor Force (in %) of Turkey in 2008 to that in 2009?
Keep it short and to the point. 0.99. What is the ratio of the Total Labor Force (in %) in Cote d'Ivoire in 2008 to that in 2010?
Ensure brevity in your answer.  1.01. What is the ratio of the Total Labor Force (in %) in Estonia in 2008 to that in 2010?
Your answer should be very brief. 1.1. What is the ratio of the Total Labor Force (in %) in Serbia in 2008 to that in 2010?
Give a very brief answer. 1.15. What is the ratio of the Total Labor Force (in %) in Cote d'Ivoire in 2008 to that in 2011?
Your answer should be very brief. 1.01. What is the ratio of the Total Labor Force (in %) in Estonia in 2008 to that in 2011?
Provide a short and direct response. 1.07. What is the ratio of the Total Labor Force (in %) in Serbia in 2008 to that in 2011?
Make the answer very short. 1.14. What is the ratio of the Total Labor Force (in %) in Turkey in 2008 to that in 2011?
Provide a short and direct response. 0.98. What is the ratio of the Total Labor Force (in %) of Estonia in 2008 to that in 2012?
Provide a succinct answer. 1.04. What is the ratio of the Total Labor Force (in %) of Serbia in 2008 to that in 2012?
Your answer should be very brief. 1.13. What is the ratio of the Total Labor Force (in %) of Estonia in 2009 to that in 2010?
Your response must be concise. 1.06. What is the ratio of the Total Labor Force (in %) of Serbia in 2009 to that in 2010?
Provide a short and direct response. 1.01. What is the ratio of the Total Labor Force (in %) in Turkey in 2009 to that in 2010?
Offer a terse response. 1.01. What is the ratio of the Total Labor Force (in %) of Estonia in 2009 to that in 2011?
Provide a short and direct response. 1.02. What is the ratio of the Total Labor Force (in %) of Serbia in 2009 to that in 2011?
Your answer should be very brief. 1. What is the ratio of the Total Labor Force (in %) in Turkey in 2009 to that in 2011?
Your answer should be compact. 0.99. What is the ratio of the Total Labor Force (in %) in Cote d'Ivoire in 2009 to that in 2012?
Keep it short and to the point. 1.01. What is the ratio of the Total Labor Force (in %) of Serbia in 2009 to that in 2012?
Give a very brief answer. 0.99. What is the ratio of the Total Labor Force (in %) in Turkey in 2009 to that in 2012?
Your answer should be compact. 1.03. What is the ratio of the Total Labor Force (in %) of Estonia in 2010 to that in 2011?
Give a very brief answer. 0.96. What is the ratio of the Total Labor Force (in %) of Estonia in 2010 to that in 2012?
Your response must be concise. 0.94. What is the ratio of the Total Labor Force (in %) in Serbia in 2010 to that in 2012?
Your response must be concise. 0.98. What is the ratio of the Total Labor Force (in %) in Turkey in 2010 to that in 2012?
Keep it short and to the point. 1.02. What is the ratio of the Total Labor Force (in %) of Estonia in 2011 to that in 2012?
Your answer should be very brief. 0.98. What is the ratio of the Total Labor Force (in %) of Serbia in 2011 to that in 2012?
Offer a very short reply. 0.99. What is the ratio of the Total Labor Force (in %) in Turkey in 2011 to that in 2012?
Your answer should be compact. 1.03. What is the difference between the highest and the second highest Total Labor Force (in %) in Cote d'Ivoire?
Provide a succinct answer. 0.1. What is the difference between the highest and the second highest Total Labor Force (in %) of Estonia?
Offer a terse response. 1.7. What is the difference between the highest and the second highest Total Labor Force (in %) in Serbia?
Provide a short and direct response. 0.2. What is the difference between the highest and the second highest Total Labor Force (in %) in Turkey?
Offer a terse response. 0.3. What is the difference between the highest and the lowest Total Labor Force (in %) of Cote d'Ivoire?
Give a very brief answer. 0.6. What is the difference between the highest and the lowest Total Labor Force (in %) of Estonia?
Keep it short and to the point. 7.3. 